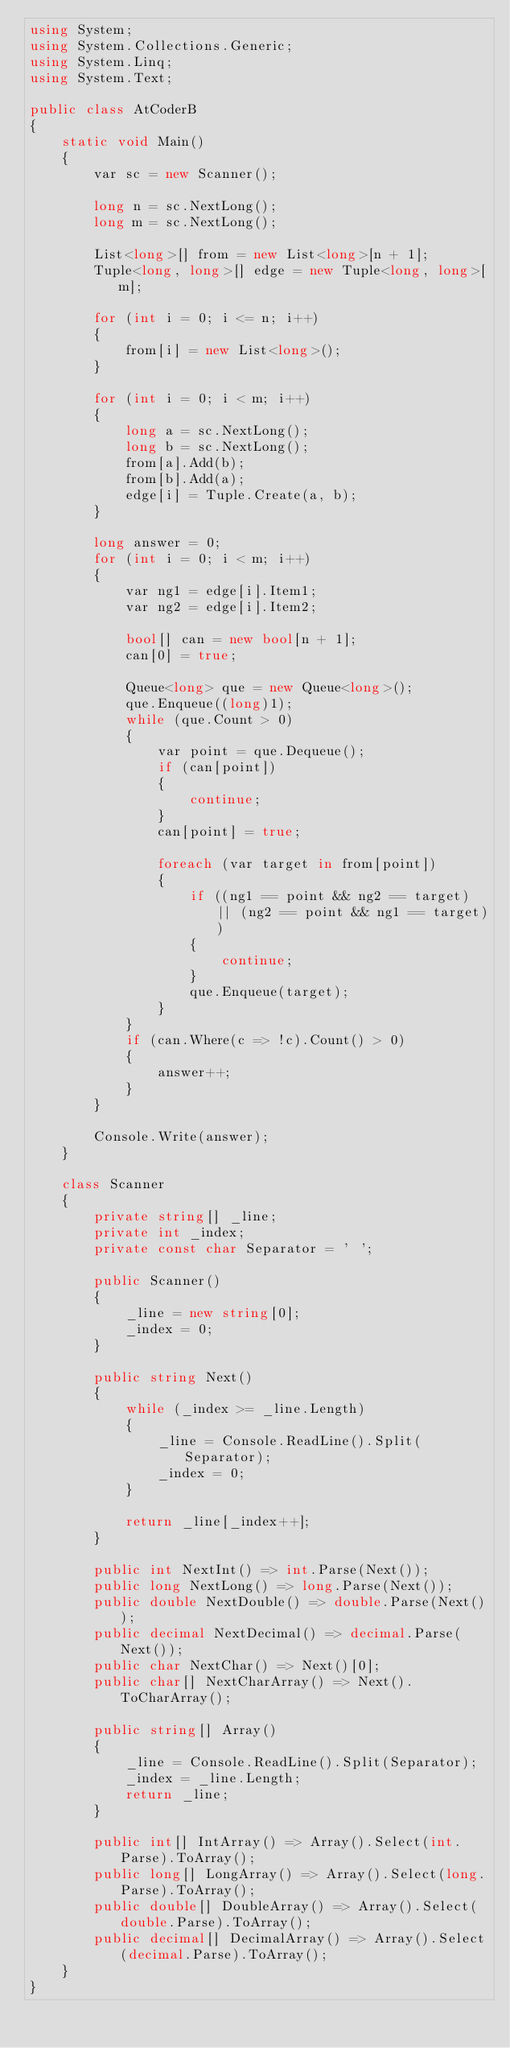<code> <loc_0><loc_0><loc_500><loc_500><_C#_>using System;
using System.Collections.Generic;
using System.Linq;
using System.Text;

public class AtCoderB
{
    static void Main()
    {
        var sc = new Scanner();

        long n = sc.NextLong();
        long m = sc.NextLong();

        List<long>[] from = new List<long>[n + 1];
        Tuple<long, long>[] edge = new Tuple<long, long>[m];

        for (int i = 0; i <= n; i++)
        {
            from[i] = new List<long>();
        }

        for (int i = 0; i < m; i++)
        {
            long a = sc.NextLong();
            long b = sc.NextLong();
            from[a].Add(b);
            from[b].Add(a);
            edge[i] = Tuple.Create(a, b);
        }

        long answer = 0;
        for (int i = 0; i < m; i++)
        {
            var ng1 = edge[i].Item1;
            var ng2 = edge[i].Item2;

            bool[] can = new bool[n + 1];
            can[0] = true;

            Queue<long> que = new Queue<long>();
            que.Enqueue((long)1);
            while (que.Count > 0)
            {
                var point = que.Dequeue();
                if (can[point])
                {
                    continue;
                }
                can[point] = true;

                foreach (var target in from[point])
                {
                    if ((ng1 == point && ng2 == target) || (ng2 == point && ng1 == target))
                    {
                        continue;
                    }
                    que.Enqueue(target);
                }
            }
            if (can.Where(c => !c).Count() > 0)
            {
                answer++;
            }
        }

        Console.Write(answer);
    }

    class Scanner
    {
        private string[] _line;
        private int _index;
        private const char Separator = ' ';

        public Scanner()
        {
            _line = new string[0];
            _index = 0;
        }

        public string Next()
        {
            while (_index >= _line.Length)
            {
                _line = Console.ReadLine().Split(Separator);
                _index = 0;
            }

            return _line[_index++];
        }

        public int NextInt() => int.Parse(Next());
        public long NextLong() => long.Parse(Next());
        public double NextDouble() => double.Parse(Next());
        public decimal NextDecimal() => decimal.Parse(Next());
        public char NextChar() => Next()[0];
        public char[] NextCharArray() => Next().ToCharArray();

        public string[] Array()
        {
            _line = Console.ReadLine().Split(Separator);
            _index = _line.Length;
            return _line;
        }

        public int[] IntArray() => Array().Select(int.Parse).ToArray();
        public long[] LongArray() => Array().Select(long.Parse).ToArray();
        public double[] DoubleArray() => Array().Select(double.Parse).ToArray();
        public decimal[] DecimalArray() => Array().Select(decimal.Parse).ToArray();
    }
}
</code> 